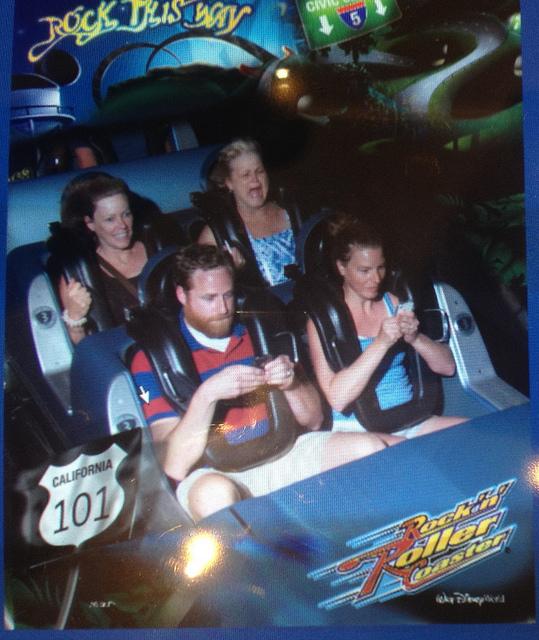What state could this roller coaster be in?
Be succinct. California. Which US Highway is referenced in this picture?
Short answer required. 101. How many people are shown on the ride?
Quick response, please. 4. Is the woman's mouth open or closed?
Keep it brief. Open. 